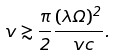<formula> <loc_0><loc_0><loc_500><loc_500>v \gtrsim \frac { \pi } { 2 } \frac { ( \lambda \Omega ) ^ { 2 } } { \ v c } .</formula> 